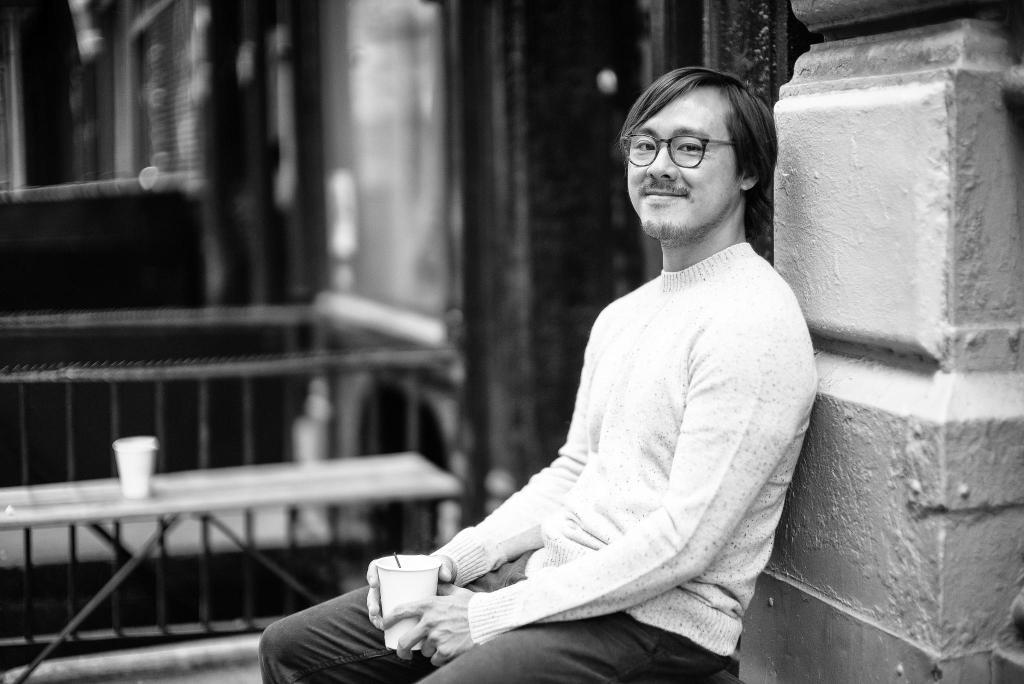What is the color scheme of the image? The image is black and white. What is the person in the image doing? The person is sitting in the image. What is the person holding? The person is holding a cup. Are there any other cups visible in the image? Yes, there is another cup on the table. What architectural features can be seen in the image? There is a pillar, a fence, and a wall in the image. What type of attraction can be seen in the image? There is no attraction present in the image; it features a person sitting and holding a cup, with a pillar, fence, and wall in the background. What type of harmony is depicted in the image? The image does not depict any specific harmony; it is a simple scene of a person sitting and holding a cup, with architectural features in the background. 